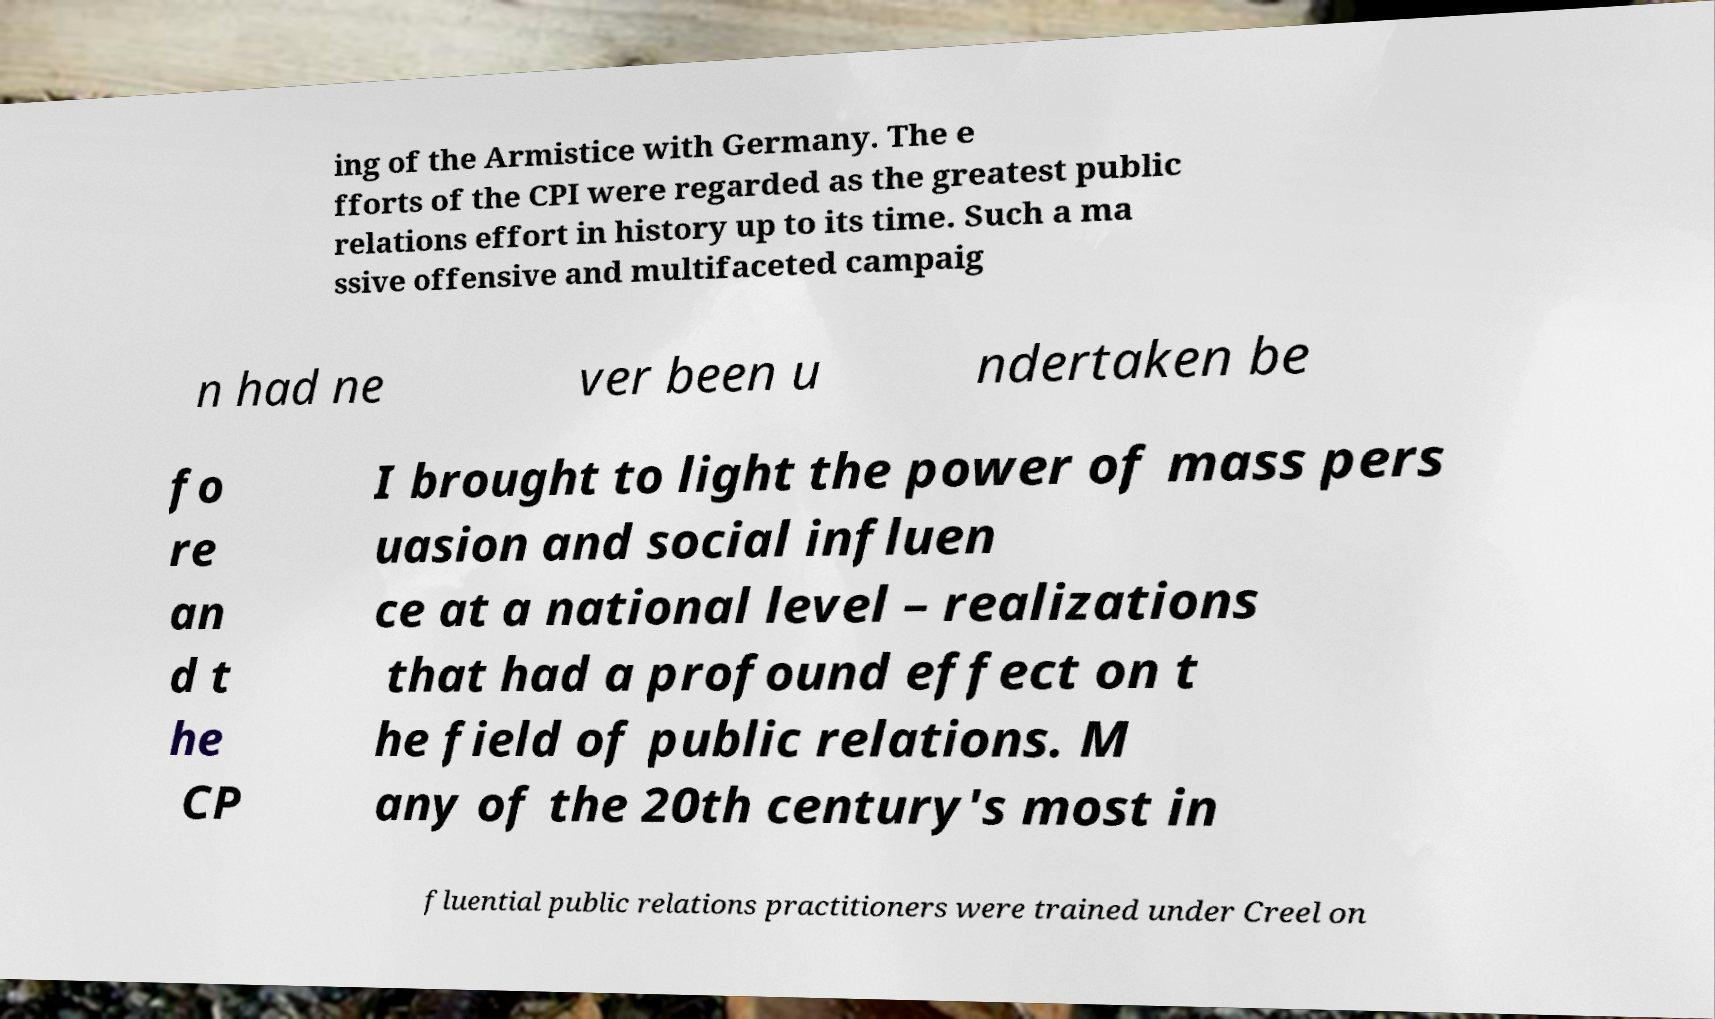Can you read and provide the text displayed in the image?This photo seems to have some interesting text. Can you extract and type it out for me? ing of the Armistice with Germany. The e fforts of the CPI were regarded as the greatest public relations effort in history up to its time. Such a ma ssive offensive and multifaceted campaig n had ne ver been u ndertaken be fo re an d t he CP I brought to light the power of mass pers uasion and social influen ce at a national level – realizations that had a profound effect on t he field of public relations. M any of the 20th century's most in fluential public relations practitioners were trained under Creel on 